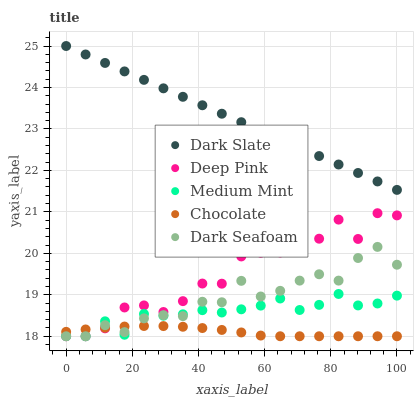Does Chocolate have the minimum area under the curve?
Answer yes or no. Yes. Does Dark Slate have the maximum area under the curve?
Answer yes or no. Yes. Does Dark Seafoam have the minimum area under the curve?
Answer yes or no. No. Does Dark Seafoam have the maximum area under the curve?
Answer yes or no. No. Is Dark Slate the smoothest?
Answer yes or no. Yes. Is Deep Pink the roughest?
Answer yes or no. Yes. Is Dark Seafoam the smoothest?
Answer yes or no. No. Is Dark Seafoam the roughest?
Answer yes or no. No. Does Medium Mint have the lowest value?
Answer yes or no. Yes. Does Dark Slate have the lowest value?
Answer yes or no. No. Does Dark Slate have the highest value?
Answer yes or no. Yes. Does Dark Seafoam have the highest value?
Answer yes or no. No. Is Dark Seafoam less than Dark Slate?
Answer yes or no. Yes. Is Dark Slate greater than Deep Pink?
Answer yes or no. Yes. Does Chocolate intersect Medium Mint?
Answer yes or no. Yes. Is Chocolate less than Medium Mint?
Answer yes or no. No. Is Chocolate greater than Medium Mint?
Answer yes or no. No. Does Dark Seafoam intersect Dark Slate?
Answer yes or no. No. 